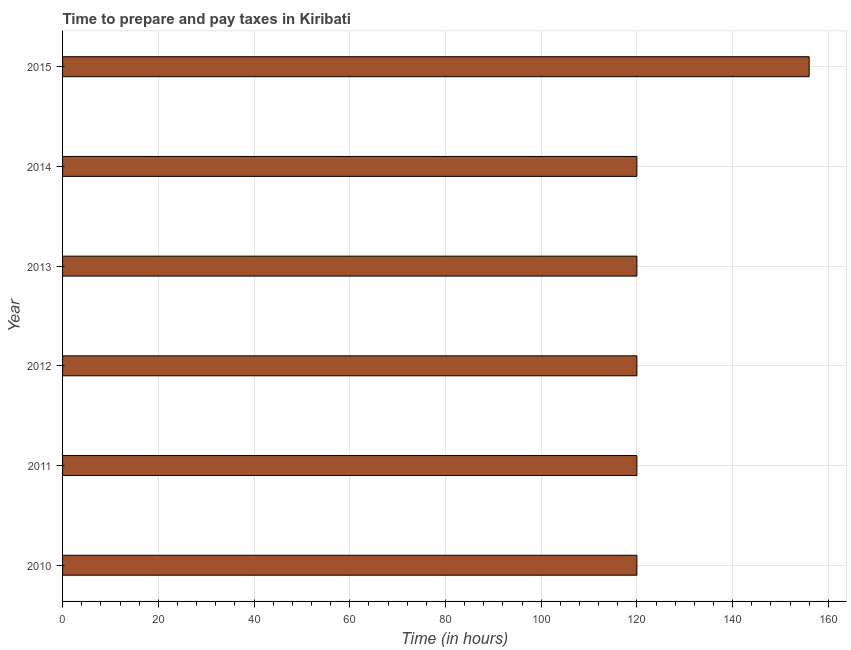What is the title of the graph?
Provide a succinct answer. Time to prepare and pay taxes in Kiribati. What is the label or title of the X-axis?
Offer a terse response. Time (in hours). What is the time to prepare and pay taxes in 2013?
Your answer should be compact. 120. Across all years, what is the maximum time to prepare and pay taxes?
Make the answer very short. 156. Across all years, what is the minimum time to prepare and pay taxes?
Make the answer very short. 120. In which year was the time to prepare and pay taxes maximum?
Offer a terse response. 2015. What is the sum of the time to prepare and pay taxes?
Keep it short and to the point. 756. What is the difference between the time to prepare and pay taxes in 2010 and 2011?
Your response must be concise. 0. What is the average time to prepare and pay taxes per year?
Make the answer very short. 126. What is the median time to prepare and pay taxes?
Your answer should be compact. 120. In how many years, is the time to prepare and pay taxes greater than 124 hours?
Provide a short and direct response. 1. Do a majority of the years between 2013 and 2012 (inclusive) have time to prepare and pay taxes greater than 44 hours?
Ensure brevity in your answer.  No. Is the time to prepare and pay taxes in 2010 less than that in 2012?
Your answer should be very brief. No. Is the sum of the time to prepare and pay taxes in 2013 and 2014 greater than the maximum time to prepare and pay taxes across all years?
Keep it short and to the point. Yes. How many years are there in the graph?
Provide a short and direct response. 6. What is the Time (in hours) in 2010?
Keep it short and to the point. 120. What is the Time (in hours) in 2011?
Your answer should be very brief. 120. What is the Time (in hours) in 2012?
Ensure brevity in your answer.  120. What is the Time (in hours) of 2013?
Provide a short and direct response. 120. What is the Time (in hours) of 2014?
Offer a very short reply. 120. What is the Time (in hours) of 2015?
Your answer should be compact. 156. What is the difference between the Time (in hours) in 2010 and 2014?
Give a very brief answer. 0. What is the difference between the Time (in hours) in 2010 and 2015?
Your answer should be compact. -36. What is the difference between the Time (in hours) in 2011 and 2014?
Offer a very short reply. 0. What is the difference between the Time (in hours) in 2011 and 2015?
Your answer should be compact. -36. What is the difference between the Time (in hours) in 2012 and 2013?
Your answer should be compact. 0. What is the difference between the Time (in hours) in 2012 and 2014?
Keep it short and to the point. 0. What is the difference between the Time (in hours) in 2012 and 2015?
Your answer should be very brief. -36. What is the difference between the Time (in hours) in 2013 and 2014?
Offer a very short reply. 0. What is the difference between the Time (in hours) in 2013 and 2015?
Offer a very short reply. -36. What is the difference between the Time (in hours) in 2014 and 2015?
Provide a short and direct response. -36. What is the ratio of the Time (in hours) in 2010 to that in 2012?
Ensure brevity in your answer.  1. What is the ratio of the Time (in hours) in 2010 to that in 2014?
Provide a short and direct response. 1. What is the ratio of the Time (in hours) in 2010 to that in 2015?
Your answer should be very brief. 0.77. What is the ratio of the Time (in hours) in 2011 to that in 2012?
Your answer should be compact. 1. What is the ratio of the Time (in hours) in 2011 to that in 2013?
Offer a terse response. 1. What is the ratio of the Time (in hours) in 2011 to that in 2015?
Give a very brief answer. 0.77. What is the ratio of the Time (in hours) in 2012 to that in 2015?
Ensure brevity in your answer.  0.77. What is the ratio of the Time (in hours) in 2013 to that in 2014?
Your answer should be compact. 1. What is the ratio of the Time (in hours) in 2013 to that in 2015?
Ensure brevity in your answer.  0.77. What is the ratio of the Time (in hours) in 2014 to that in 2015?
Keep it short and to the point. 0.77. 